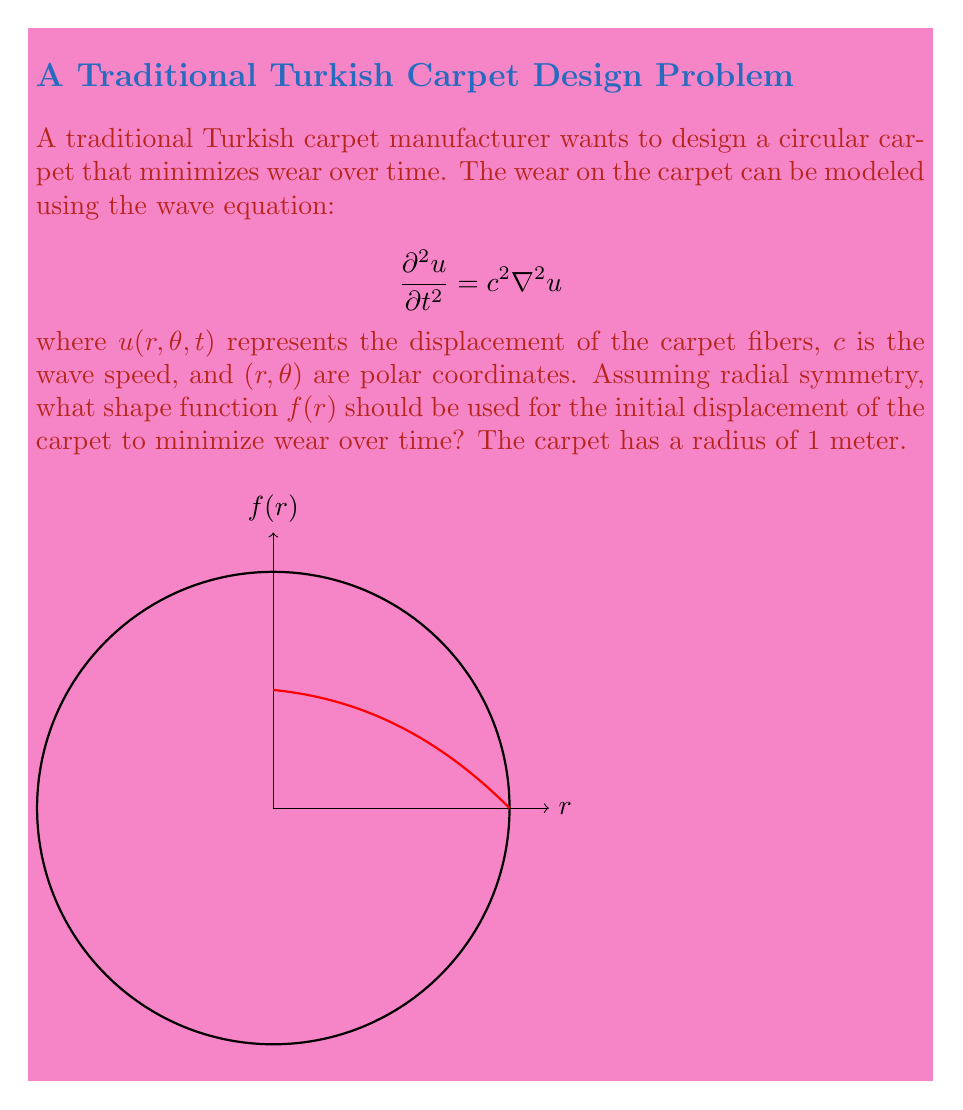What is the answer to this math problem? To solve this problem, we follow these steps:

1) Given radial symmetry, the wave equation in polar coordinates reduces to:

   $$\frac{\partial^2 u}{\partial t^2} = c^2 \left(\frac{\partial^2 u}{\partial r^2} + \frac{1}{r}\frac{\partial u}{\partial r}\right)$$

2) We seek a solution of the form $u(r,t) = f(r)T(t)$. Substituting this into the wave equation:

   $$f(r)T''(t) = c^2 \left(f''(r)T(t) + \frac{1}{r}f'(r)T(t)\right)$$

3) Separating variables:

   $$\frac{T''(t)}{c^2T(t)} = \frac{f''(r) + \frac{1}{r}f'(r)}{f(r)} = -\lambda^2$$

   where $\lambda$ is a separation constant.

4) The temporal part gives: $T(t) = A\cos(\lambda ct) + B\sin(\lambda ct)$

5) The radial part leads to Bessel's equation:

   $$r^2f''(r) + rf'(r) + \lambda^2r^2f(r) = 0$$

6) The solution to this is the Bessel function of the first kind, $J_0(\lambda r)$.

7) To minimize wear, we want the lowest frequency mode, which corresponds to the smallest $\lambda$ that satisfies the boundary condition $J_0(\lambda) = 0$.

8) The smallest positive root of $J_0(x) = 0$ is approximately 2.4048.

9) Therefore, the optimal shape function is:

   $$f(r) = J_0(2.4048r)$$

This shape will result in the least amount of oscillation and thus minimize wear over time.
Answer: $f(r) = J_0(2.4048r)$ 